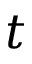Convert formula to latex. <formula><loc_0><loc_0><loc_500><loc_500>t</formula> 